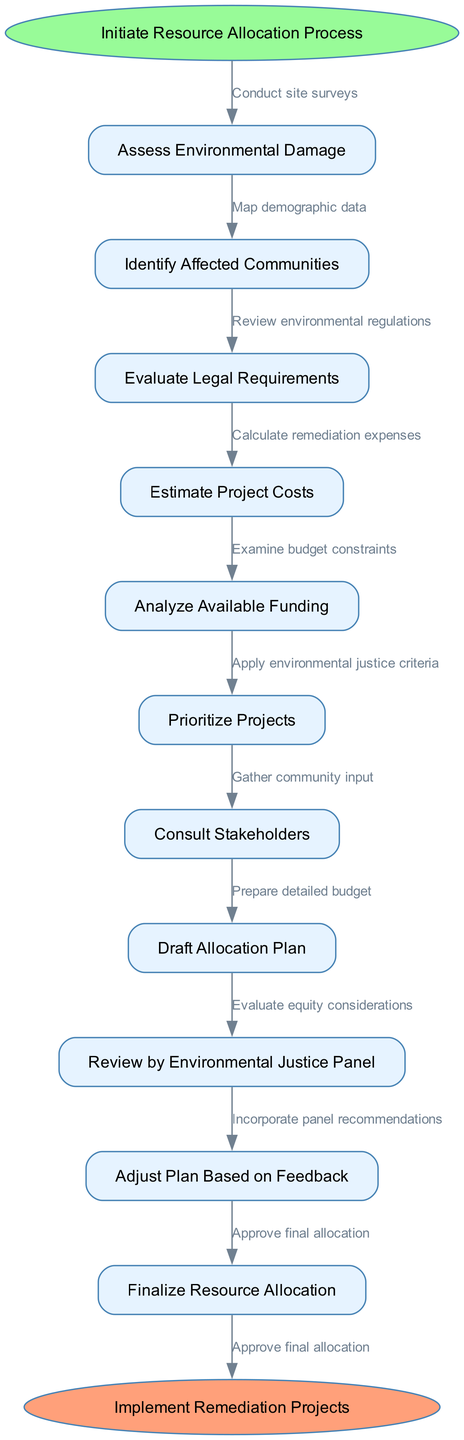What is the starting point of the process? The starting point of the process is clearly defined as "Initiate Resource Allocation Process" in the diagram. This is indicated by the first node connected to the starting ellipse.
Answer: Initiate Resource Allocation Process How many nodes are present in the flow chart? The flow chart contains a total of eleven nodes, including the starting and ending points. This can be confirmed by counting each distinct function represented in the diagram.
Answer: 11 Which node follows "Assess Environmental Damage"? Following "Assess Environmental Damage", the next node in the sequential flow is "Identify Affected Communities". This is represented by the direct edge connecting these two nodes in the diagram.
Answer: Identify Affected Communities What is the final step in the resource allocation process? The final step indicated in the flow chart is "Implement Remediation Projects", represented as the endpoint of the diagram and connected from the last process node.
Answer: Implement Remediation Projects How many edges connect the nodes in the diagram? There are ten edges in total that connect the nodes, which includes steps or actions that transition from one node to the next in the process. This can be confirmed by counting all connections between resolved nodes.
Answer: 10 What criteria is applied to prioritize projects? The flow chart specifies that "Apply environmental justice criteria" is used to prioritize projects, indicating that environmental fairness is a filtering factor before final decisions.
Answer: Apply environmental justice criteria What happens after "Consult Stakeholders"? After "Consult Stakeholders", the next action in the flow is to "Draft Allocation Plan". This follows logically as community input gathered would inform how resources should be allocated.
Answer: Draft Allocation Plan How does the process adjust the initial allocation plan? The process includes an adjustment step called "Adjust Plan Based on Feedback" after receiving input from the "Review by Environmental Justice Panel", incorporating their feedback into the allocation plan.
Answer: Adjust Plan Based on Feedback Which node evaluates legal requirements? The evaluation of legal requirements is handled by the node titled "Evaluate Legal Requirements". This is a distinct step that occurs after assessing environmental damage and before estimating project costs in the diagram.
Answer: Evaluate Legal Requirements 